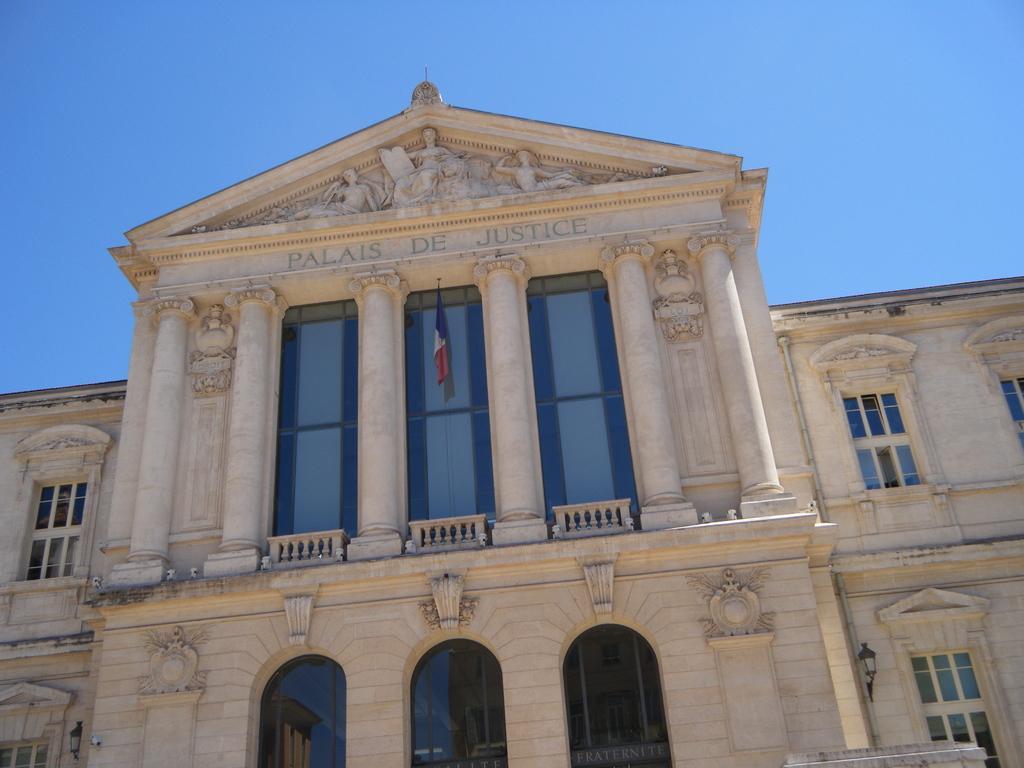Describe this image in one or two sentences. In the image I can see the building, windows, lights and the flag. The sky is in blue color. 